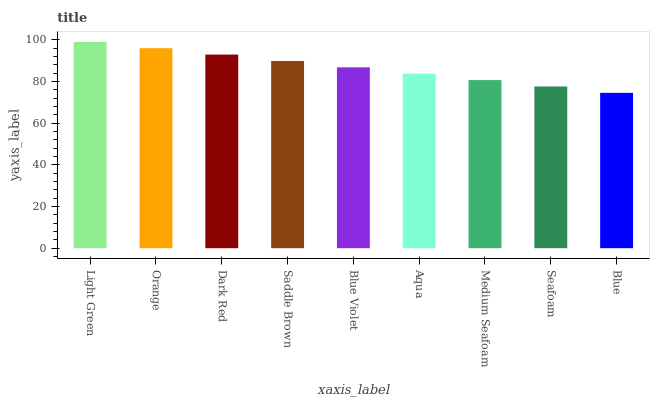Is Blue the minimum?
Answer yes or no. Yes. Is Light Green the maximum?
Answer yes or no. Yes. Is Orange the minimum?
Answer yes or no. No. Is Orange the maximum?
Answer yes or no. No. Is Light Green greater than Orange?
Answer yes or no. Yes. Is Orange less than Light Green?
Answer yes or no. Yes. Is Orange greater than Light Green?
Answer yes or no. No. Is Light Green less than Orange?
Answer yes or no. No. Is Blue Violet the high median?
Answer yes or no. Yes. Is Blue Violet the low median?
Answer yes or no. Yes. Is Orange the high median?
Answer yes or no. No. Is Orange the low median?
Answer yes or no. No. 